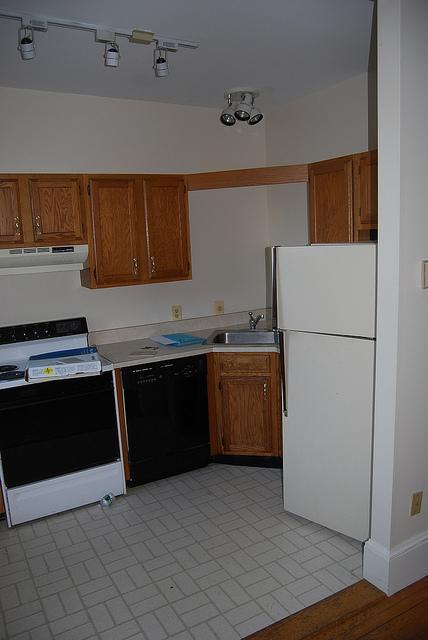How many lights are on the ceiling?
Give a very brief answer. 6. How many microwaves are in the picture?
Give a very brief answer. 0. How many pictures are there?
Give a very brief answer. 0. 